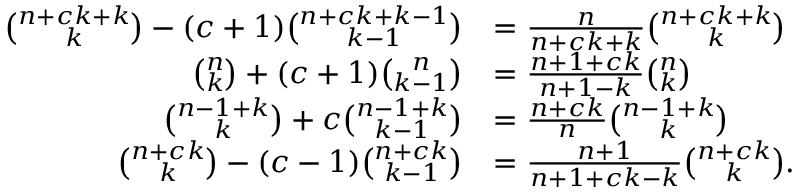<formula> <loc_0><loc_0><loc_500><loc_500>{ \begin{array} { r l } { { \binom { n + c k + k } { k } } - ( c + 1 ) { \binom { n + c k + k - 1 } { k - 1 } } } & { = { \frac { n } { n + c k + k } } { \binom { n + c k + k } { k } } } \\ { { \binom { n } { k } } + ( c + 1 ) { \binom { n } { k - 1 } } } & { = { \frac { n + 1 + c k } { n + 1 - k } } { \binom { n } { k } } } \\ { { \binom { n - 1 + k } { k } } + c { \binom { n - 1 + k } { k - 1 } } } & { = { \frac { n + c k } { n } } { \binom { n - 1 + k } { k } } } \\ { { \binom { n + c k } { k } } - ( c - 1 ) { \binom { n + c k } { k - 1 } } } & { = { \frac { n + 1 } { n + 1 + c k - k } } { \binom { n + c k } { k } } . } \end{array} }</formula> 